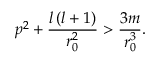Convert formula to latex. <formula><loc_0><loc_0><loc_500><loc_500>p ^ { 2 } + \frac { l \left ( l + 1 \right ) } { r _ { 0 } ^ { 2 } } > \frac { 3 m } { r _ { 0 } ^ { 3 } } .</formula> 